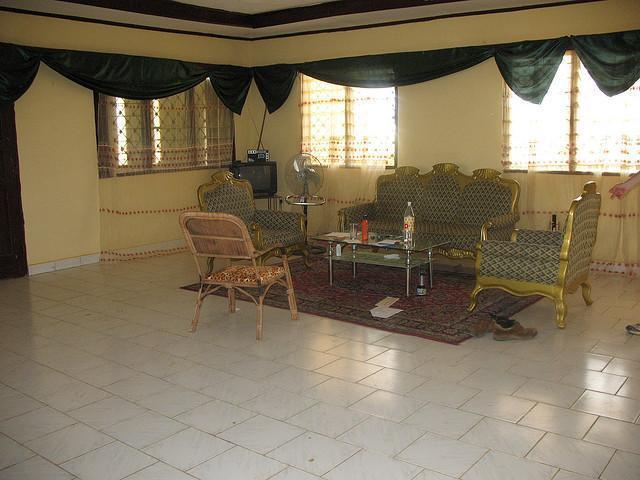How many windows are there?
Give a very brief answer. 3. How many chairs are visible?
Give a very brief answer. 3. 